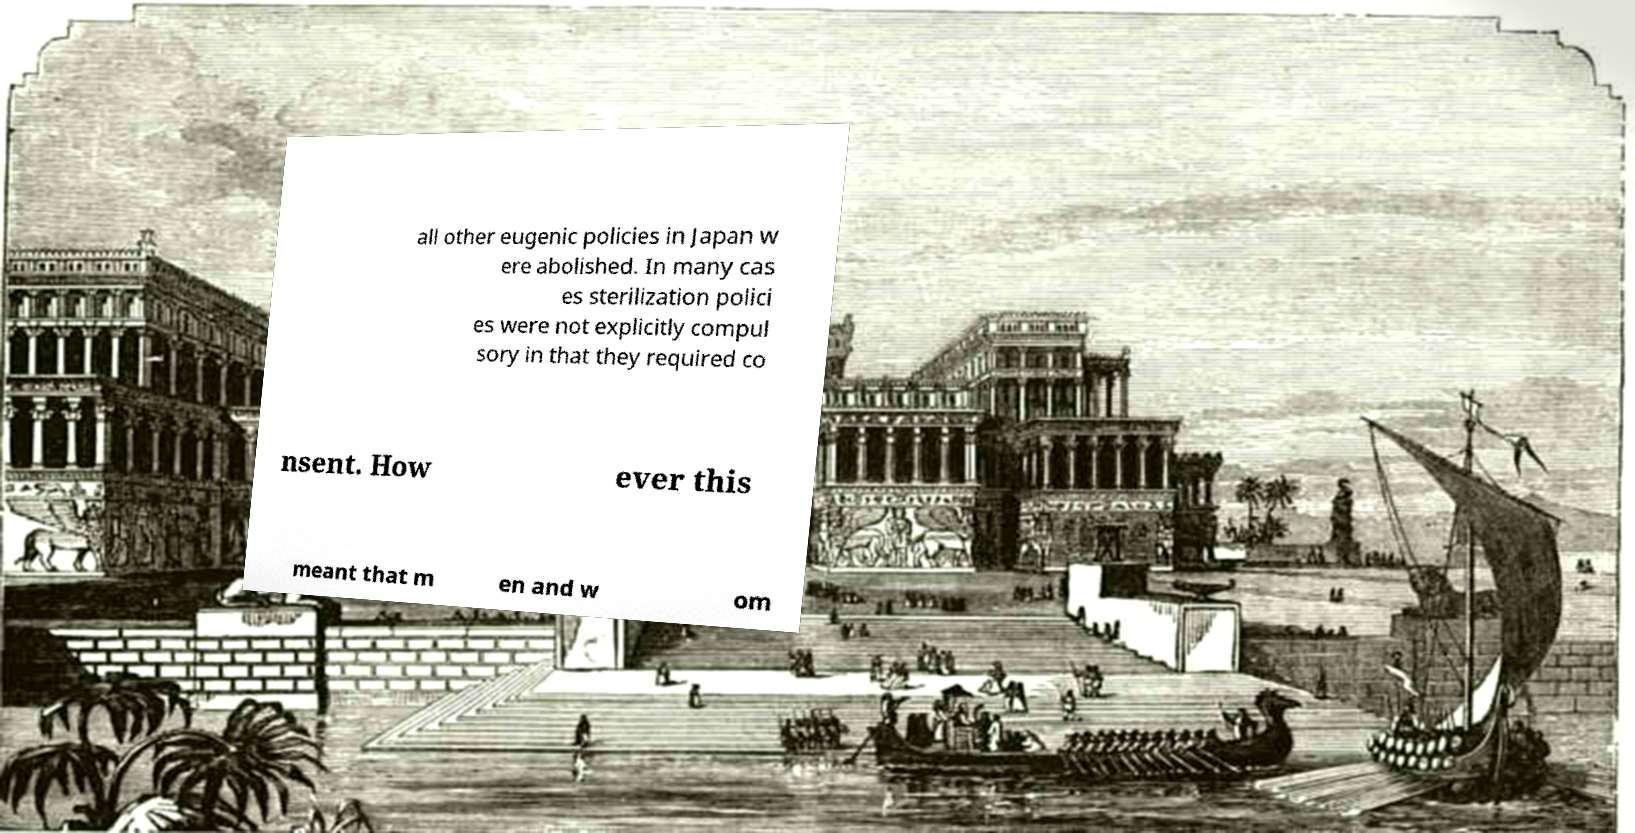There's text embedded in this image that I need extracted. Can you transcribe it verbatim? all other eugenic policies in Japan w ere abolished. In many cas es sterilization polici es were not explicitly compul sory in that they required co nsent. How ever this meant that m en and w om 